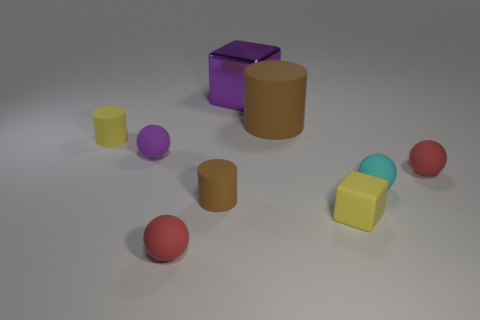Add 1 small cylinders. How many objects exist? 10 Subtract all cubes. How many objects are left? 7 Subtract all purple objects. Subtract all small yellow cubes. How many objects are left? 6 Add 2 big shiny things. How many big shiny things are left? 3 Add 6 big green blocks. How many big green blocks exist? 6 Subtract 1 yellow cubes. How many objects are left? 8 